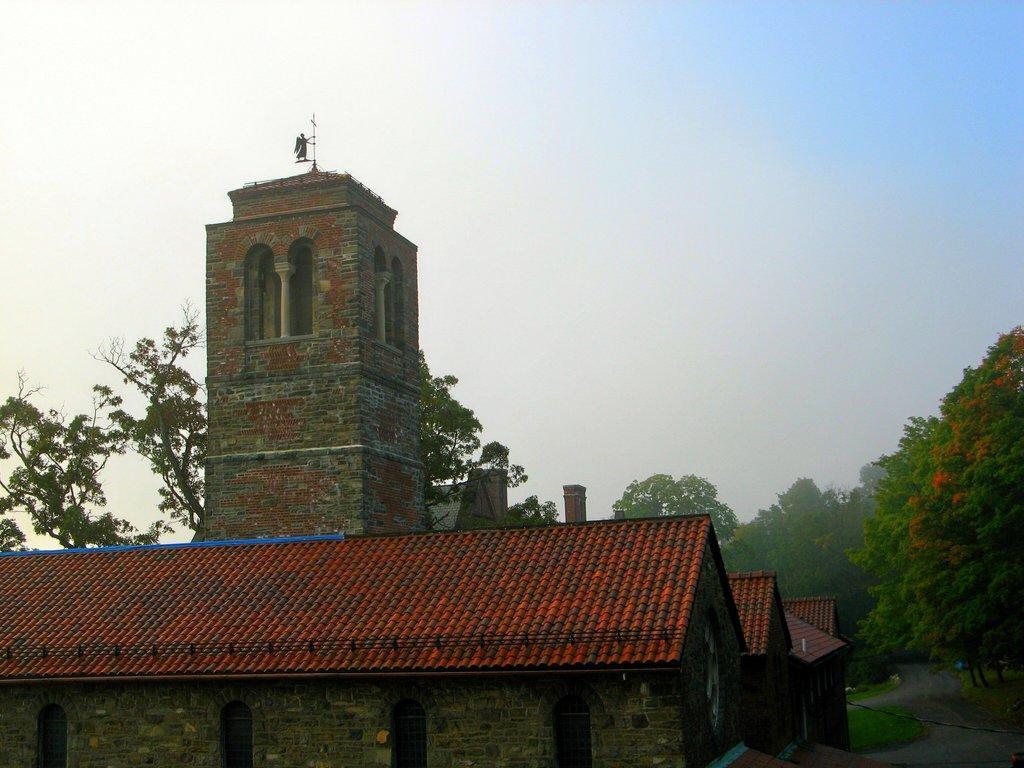Could you give a brief overview of what you see in this image? At the bottom of the picture, we see buildings with a red color roof. Behind that, we see a tower. There are many trees in the background. At the top of the picture, we see the sky. 